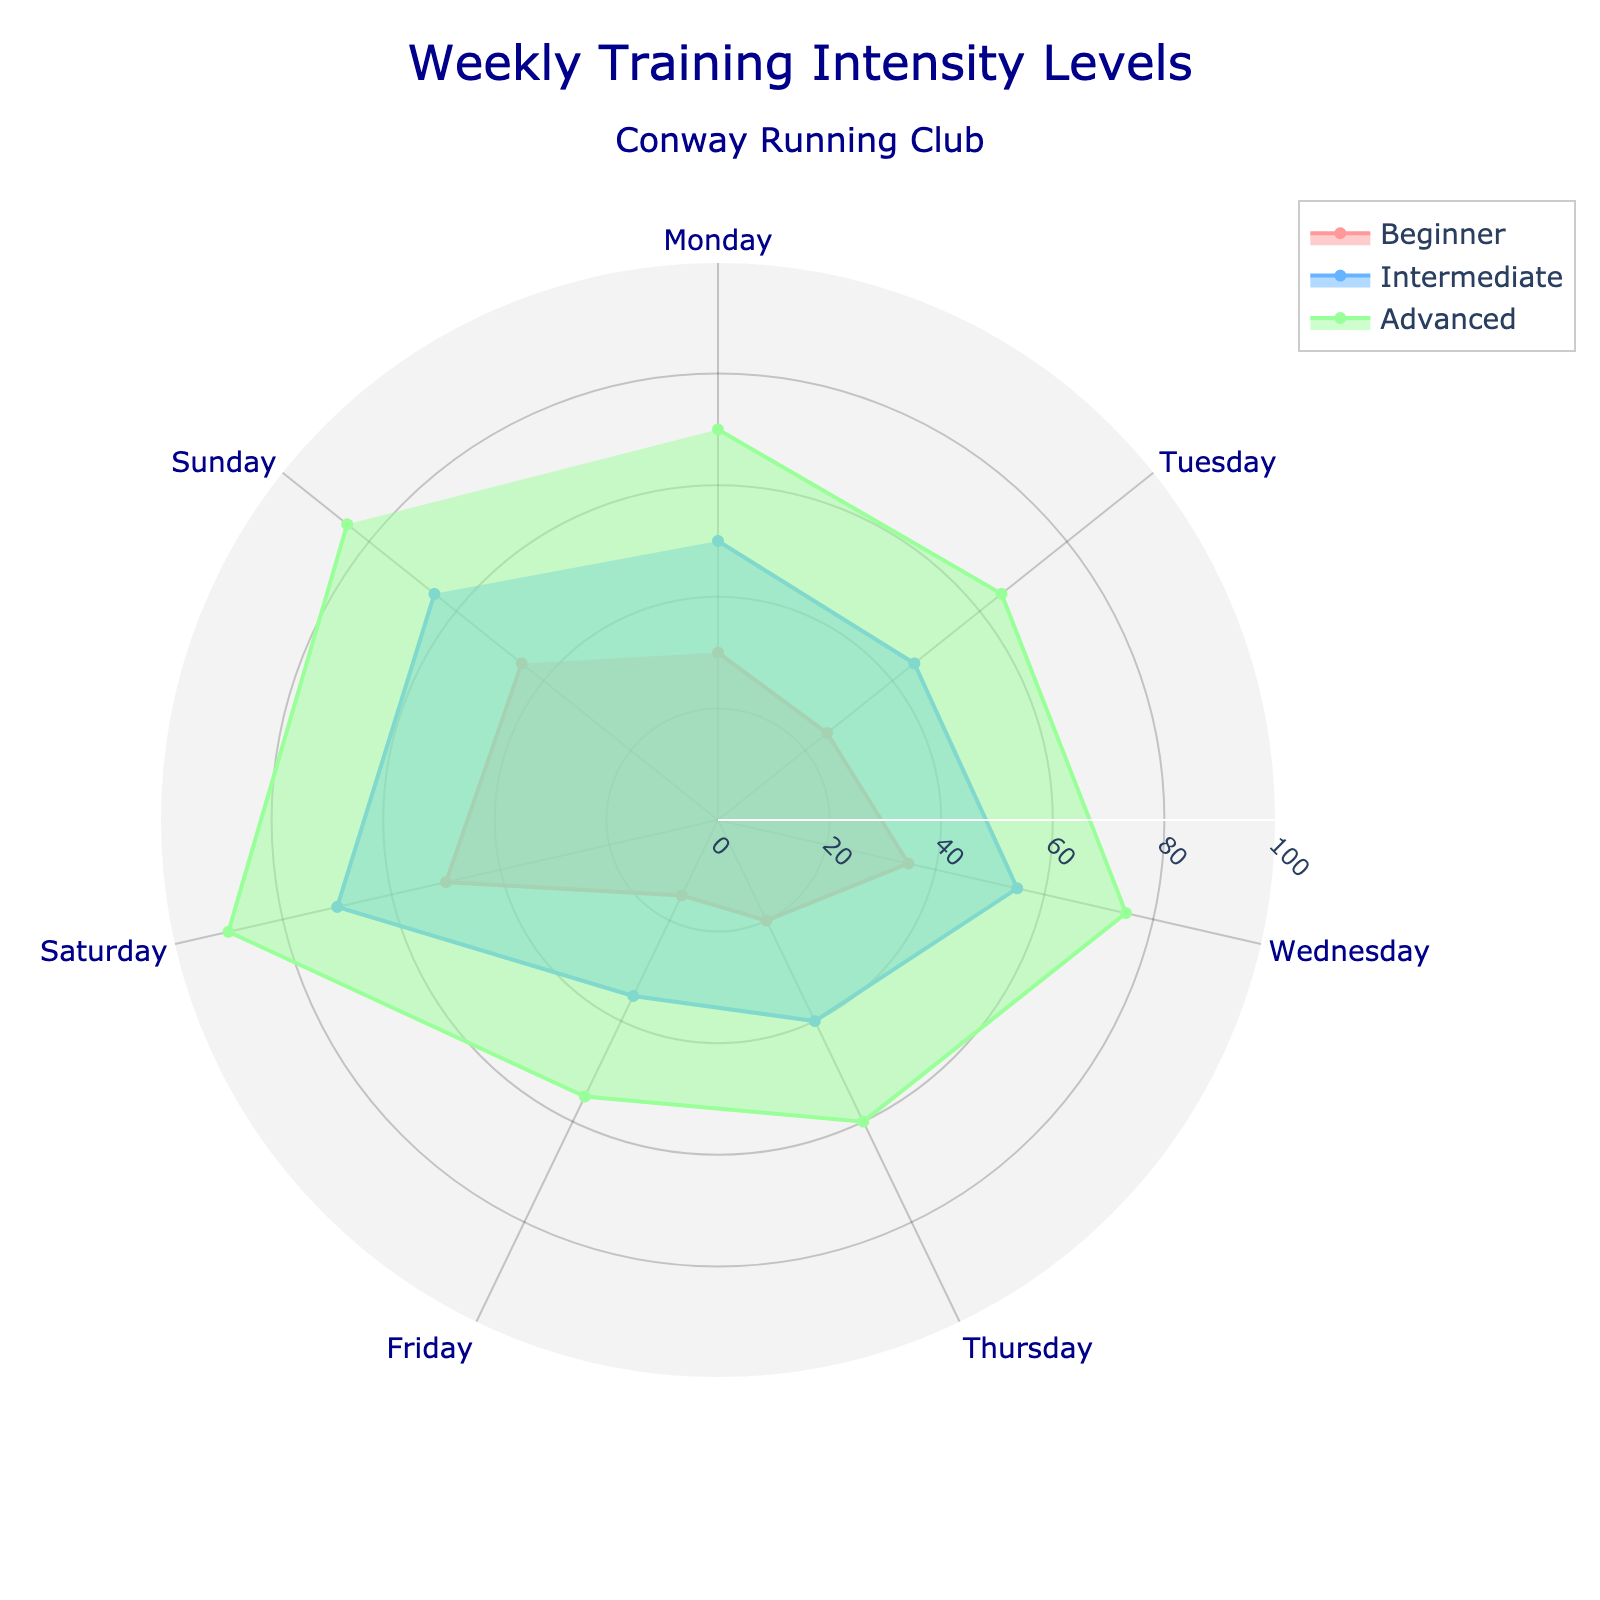What is the title of the figure? The title of the figure is typically located at the top center and provides an overview of the chart's content. By reading from the top, we see it is "Weekly Training Intensity Levels" with a subtitle specifying "Conway Running Club".
Answer: Weekly Training Intensity Levels (Conway Running Club) Which day has the highest training intensity for advanced runners? Look for the largest value in the 'Advanced' category spread around different days. The highest intensity for advanced runners is seen on Saturday.
Answer: Saturday How does the training intensity level of beginners on Wednesday compare to that on Thursday? Visualize the relative lengths of the segments on Wednesday and Thursday within the 'Beginner' category. The intensity is higher on Wednesday (35) compared to Thursday (20).
Answer: Higher on Wednesday Which day shows the lowest training intensity for intermediate runners? Identify the smallest segment length for the 'Intermediate' category across all days of the week. On Friday, the intensity is 35, which is the lowest.
Answer: Friday What is the average training intensity level for beginners throughout the week? Sum the intensity values for beginners for each day and then divide by 7 (number of days). Calculation: (30+25+35+20+15+50+45)/7 = 220/7 ≈ 31.43.
Answer: 31.43 Which days have the same training intensity for both beginner and intermediate runners? Compare segment lengths for both beginner and intermediate values to find matching ones. No days have matching intensity levels for these two groups.
Answer: None What is the difference in training intensity levels between advanced and beginner runners on Tuesday? Subtract the training intensity level for beginners from that of advanced runners on Tuesday. Calculation: 65 (Advanced) - 25 (Beginner) = 40.
Answer: 40 On which day is the training intensity for intermediate runners closest to 50? Find the day where the intermediate training intensity is nearest to 50. On Monday, the intensity is 50.
Answer: Monday What is the sum of training intensities for advanced runners over the weekend (Saturday and Sunday)? Sum the intensity values for the 'Advanced' category on Saturday and Sunday. Calculation: 90 (Saturday) + 85 (Sunday) = 175.
Answer: 175 Which category has the most variation in training intensity levels throughout the week? Look at the range of values (maximum - minimum) for beginners, intermediate, and advanced categories. Advanced has the range of 90-55=35, Intermediate has 70-35=35, and Beginner has 50-15=35, so they all have the same range. However, considering the visual plot, Advanced shows more spread visually.
Answer: Advanced 